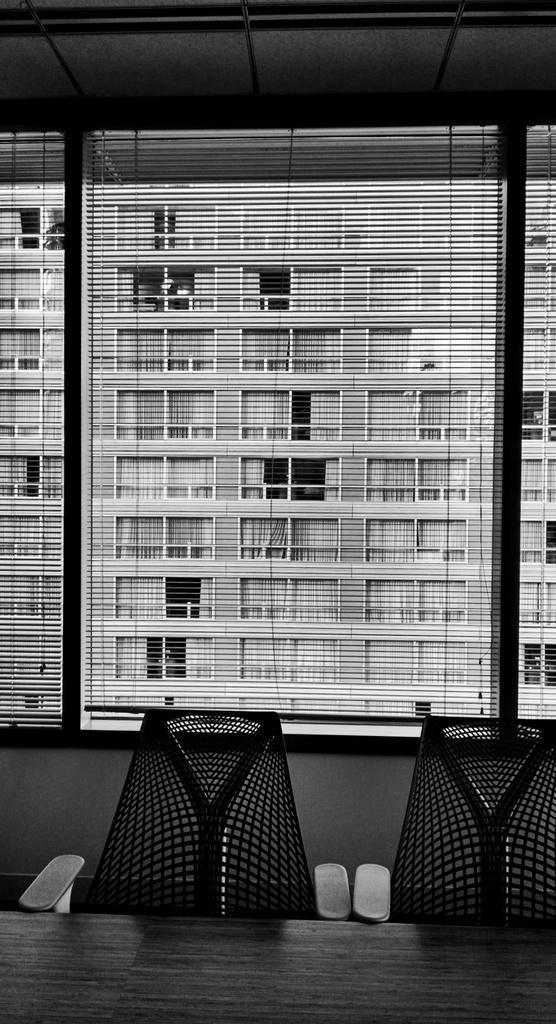How would you summarize this image in a sentence or two? In this picture we can see couple of chairs and a table, in the background we can see a building, and it is a black and white photography. 